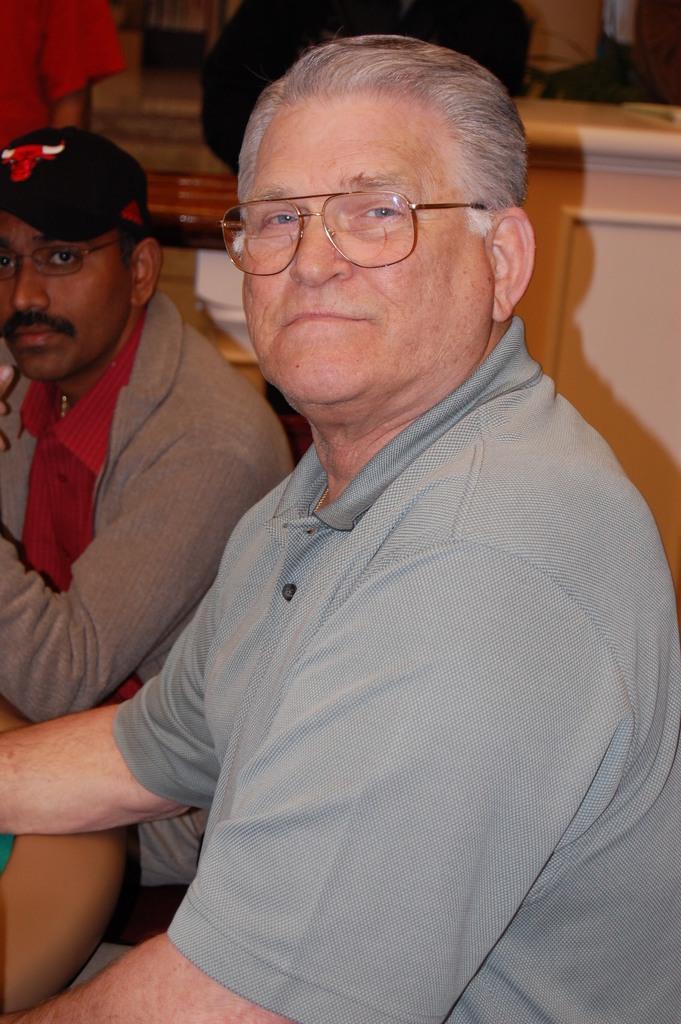Could you give a brief overview of what you see in this image? In this picture we can see there are two people with spectacles and a person with a cap. Behind the people there are two people standing and some objects. 